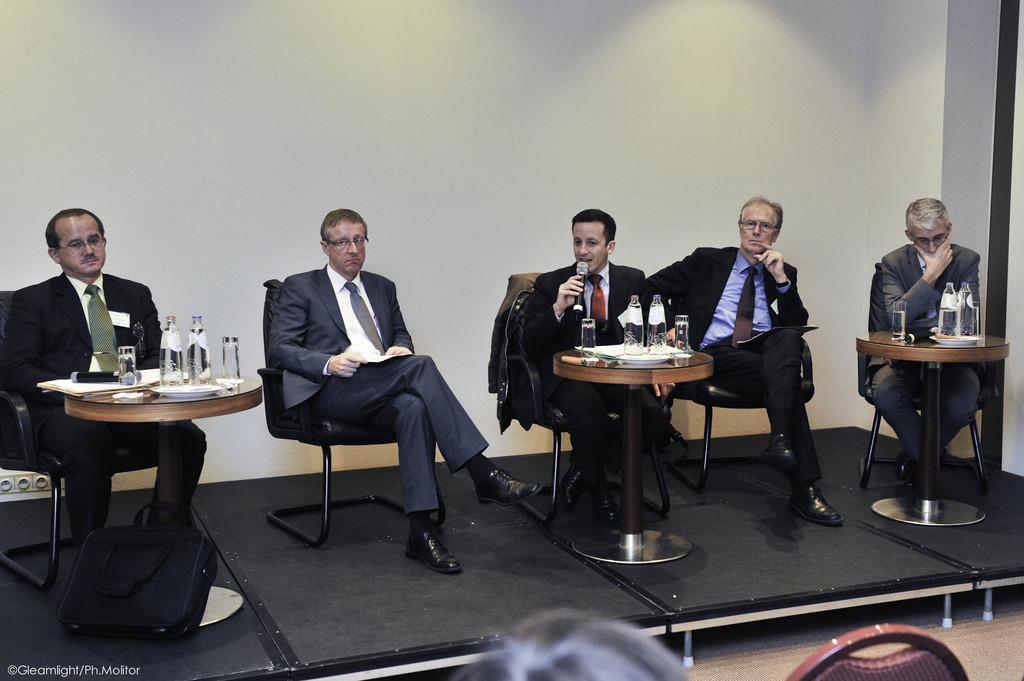In one or two sentences, can you explain what this image depicts? There are five members sitting in the chairs. Three of them were in front of a tables on which some water bottles and glasses, along with some papers were placed. One of the guy is holding a mic in his hand. In the background there is a wall. 